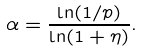<formula> <loc_0><loc_0><loc_500><loc_500>\alpha = \frac { \ln ( 1 / p ) } { \ln ( 1 + \eta ) } .</formula> 